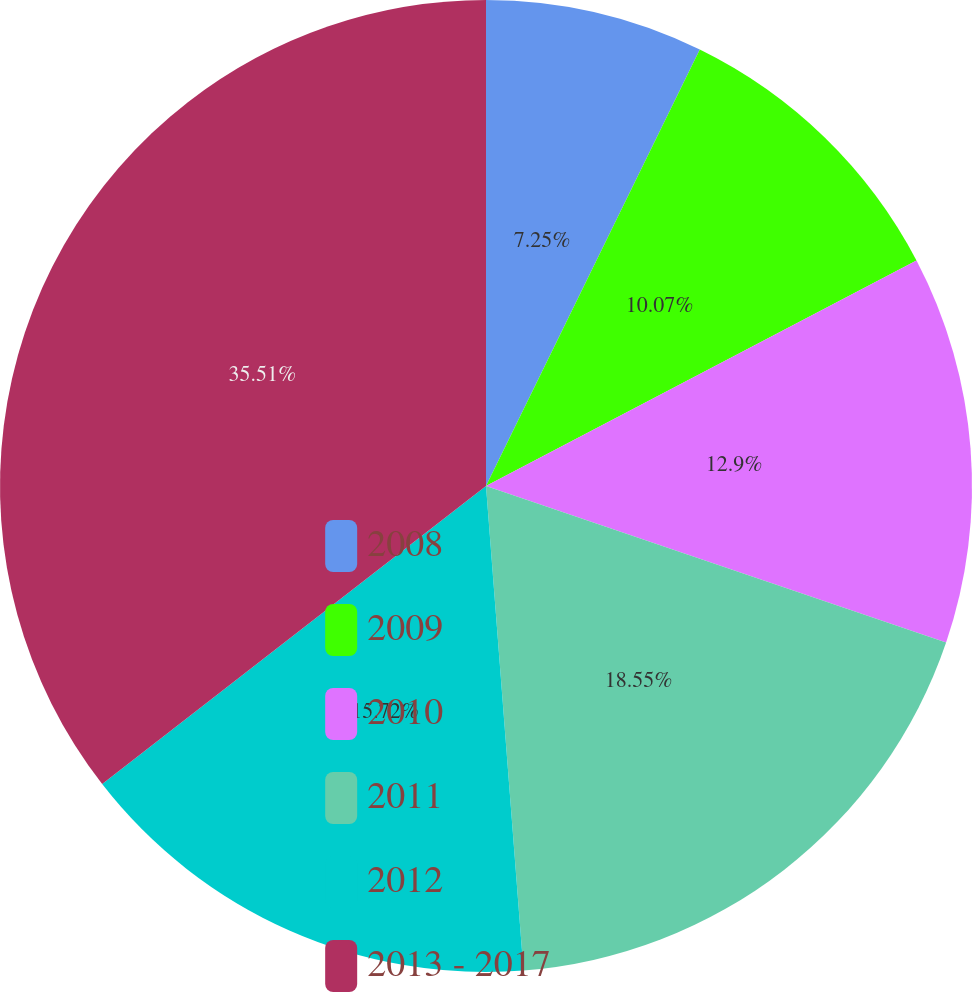<chart> <loc_0><loc_0><loc_500><loc_500><pie_chart><fcel>2008<fcel>2009<fcel>2010<fcel>2011<fcel>2012<fcel>2013 - 2017<nl><fcel>7.25%<fcel>10.07%<fcel>12.9%<fcel>18.55%<fcel>15.72%<fcel>35.51%<nl></chart> 